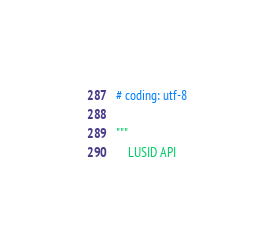<code> <loc_0><loc_0><loc_500><loc_500><_Python_># coding: utf-8

"""
    LUSID API
</code> 